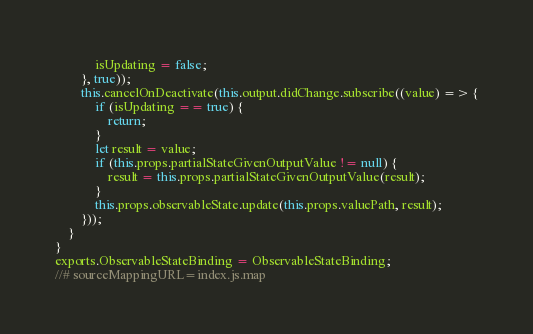Convert code to text. <code><loc_0><loc_0><loc_500><loc_500><_JavaScript_>            isUpdating = false;
        }, true));
        this.cancelOnDeactivate(this.output.didChange.subscribe((value) => {
            if (isUpdating == true) {
                return;
            }
            let result = value;
            if (this.props.partialStateGivenOutputValue != null) {
                result = this.props.partialStateGivenOutputValue(result);
            }
            this.props.observableState.update(this.props.valuePath, result);
        }));
    }
}
exports.ObservableStateBinding = ObservableStateBinding;
//# sourceMappingURL=index.js.map</code> 